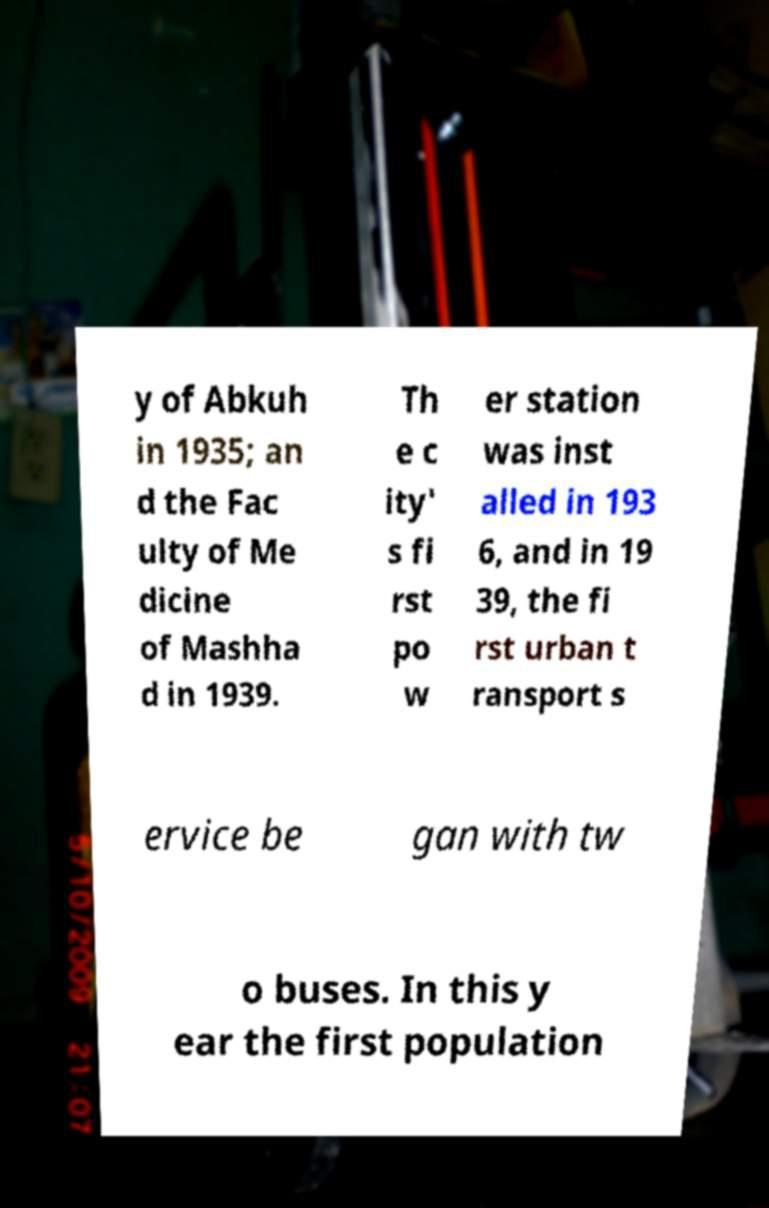Could you assist in decoding the text presented in this image and type it out clearly? y of Abkuh in 1935; an d the Fac ulty of Me dicine of Mashha d in 1939. Th e c ity' s fi rst po w er station was inst alled in 193 6, and in 19 39, the fi rst urban t ransport s ervice be gan with tw o buses. In this y ear the first population 